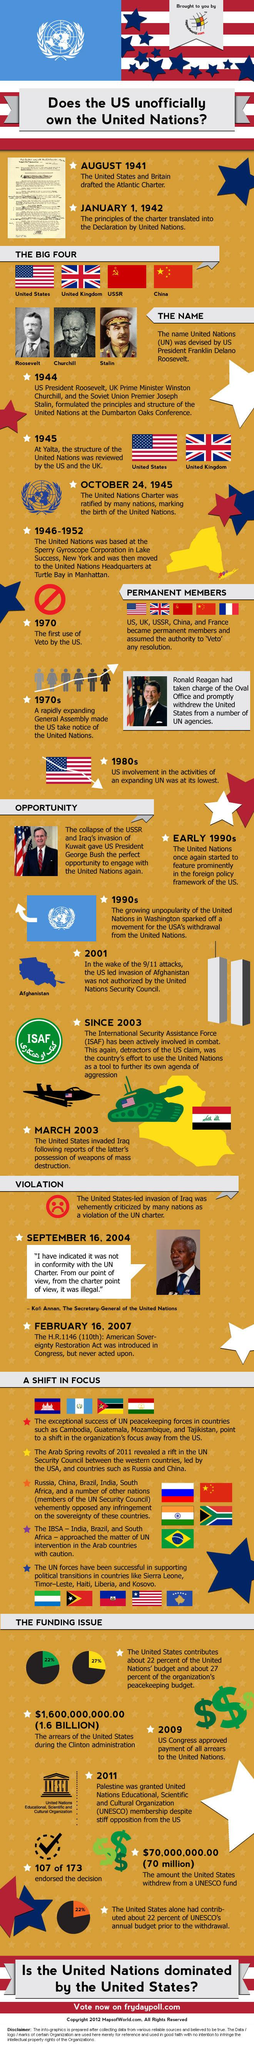Point out several critical features in this image. The United States withdrew from the United Nations during the 1970s and 1990s. The IBSA is comprised of three countries. The United Nations peacekeeping forces have played a significant role in multiple countries around the world. The United States was the first country to exercise veto power. Franklin D. Roosevelt was involved in the ideation of the United Nations, and he played a significant role in its establishment. 